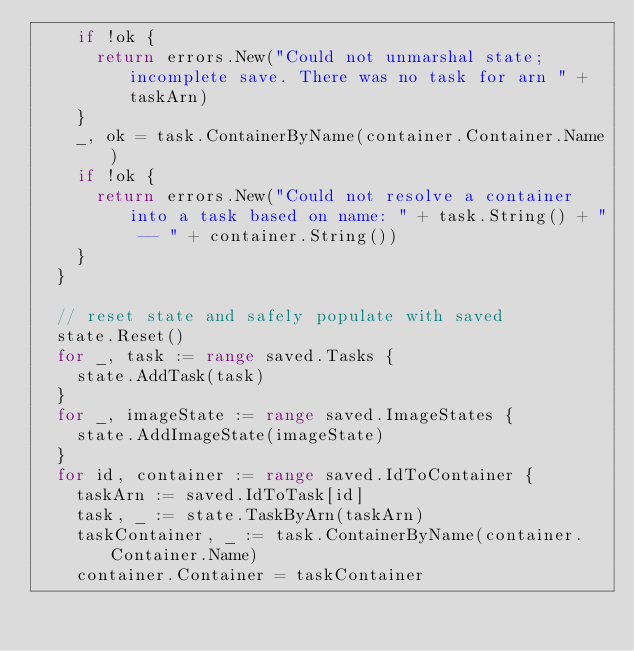<code> <loc_0><loc_0><loc_500><loc_500><_Go_>		if !ok {
			return errors.New("Could not unmarshal state; incomplete save. There was no task for arn " + taskArn)
		}
		_, ok = task.ContainerByName(container.Container.Name)
		if !ok {
			return errors.New("Could not resolve a container into a task based on name: " + task.String() + " -- " + container.String())
		}
	}

	// reset state and safely populate with saved
	state.Reset()
	for _, task := range saved.Tasks {
		state.AddTask(task)
	}
	for _, imageState := range saved.ImageStates {
		state.AddImageState(imageState)
	}
	for id, container := range saved.IdToContainer {
		taskArn := saved.IdToTask[id]
		task, _ := state.TaskByArn(taskArn)
		taskContainer, _ := task.ContainerByName(container.Container.Name)
		container.Container = taskContainer</code> 